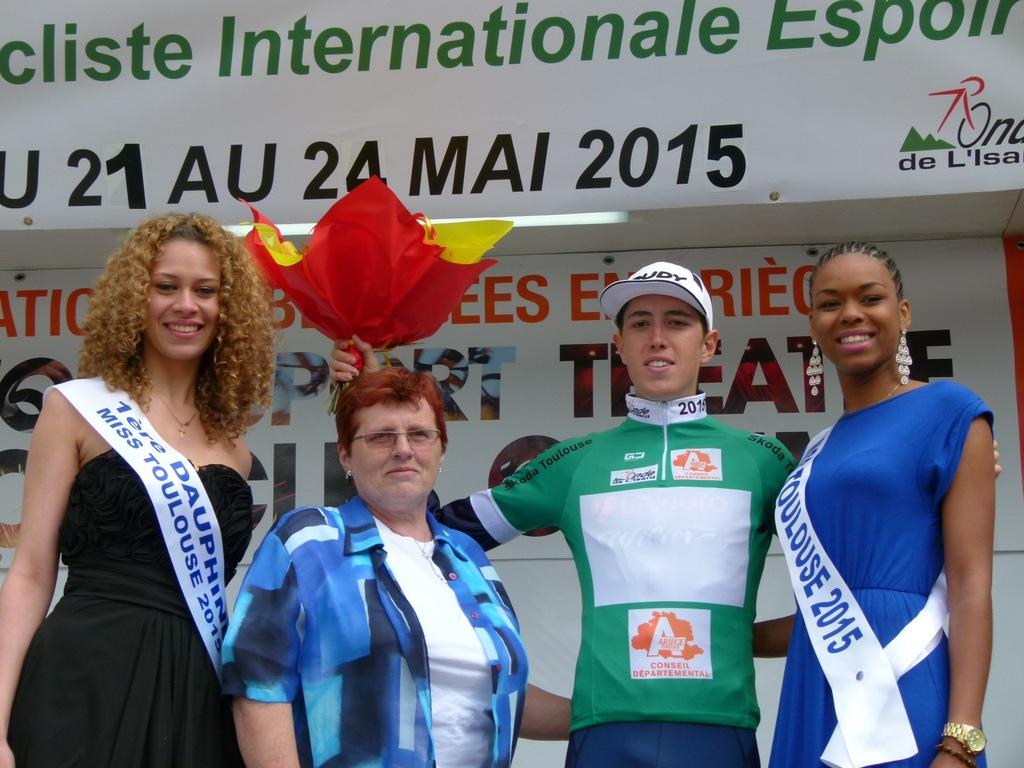Provide a one-sentence caption for the provided image. Miss Toulouse 2015 poses with various people in front of a banner. 